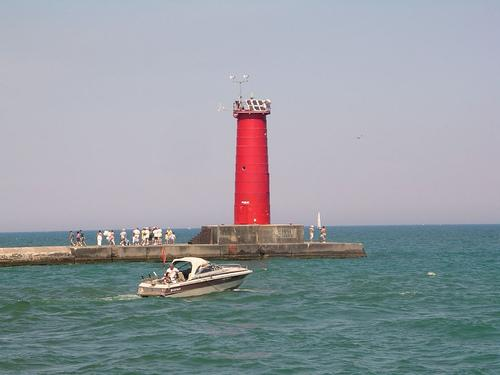What purpose does the red tower serve? lighthouse 